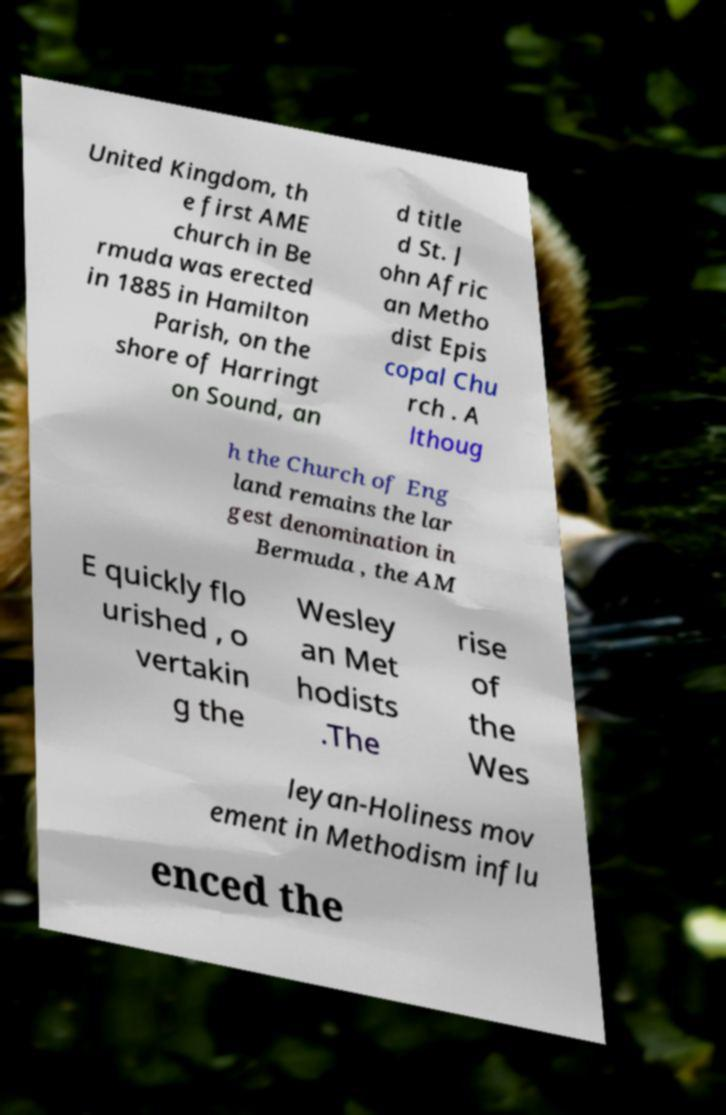Can you read and provide the text displayed in the image?This photo seems to have some interesting text. Can you extract and type it out for me? United Kingdom, th e first AME church in Be rmuda was erected in 1885 in Hamilton Parish, on the shore of Harringt on Sound, an d title d St. J ohn Afric an Metho dist Epis copal Chu rch . A lthoug h the Church of Eng land remains the lar gest denomination in Bermuda , the AM E quickly flo urished , o vertakin g the Wesley an Met hodists .The rise of the Wes leyan-Holiness mov ement in Methodism influ enced the 